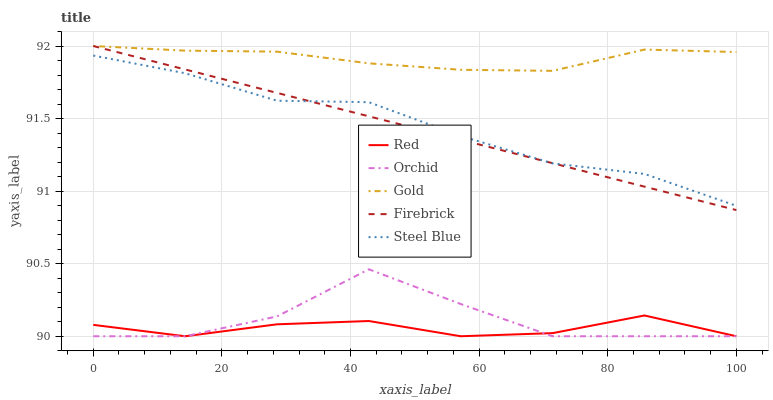Does Red have the minimum area under the curve?
Answer yes or no. Yes. Does Gold have the maximum area under the curve?
Answer yes or no. Yes. Does Steel Blue have the minimum area under the curve?
Answer yes or no. No. Does Steel Blue have the maximum area under the curve?
Answer yes or no. No. Is Firebrick the smoothest?
Answer yes or no. Yes. Is Orchid the roughest?
Answer yes or no. Yes. Is Steel Blue the smoothest?
Answer yes or no. No. Is Steel Blue the roughest?
Answer yes or no. No. Does Steel Blue have the lowest value?
Answer yes or no. No. Does Gold have the highest value?
Answer yes or no. Yes. Does Steel Blue have the highest value?
Answer yes or no. No. Is Red less than Firebrick?
Answer yes or no. Yes. Is Firebrick greater than Orchid?
Answer yes or no. Yes. Does Firebrick intersect Gold?
Answer yes or no. Yes. Is Firebrick less than Gold?
Answer yes or no. No. Is Firebrick greater than Gold?
Answer yes or no. No. Does Red intersect Firebrick?
Answer yes or no. No. 